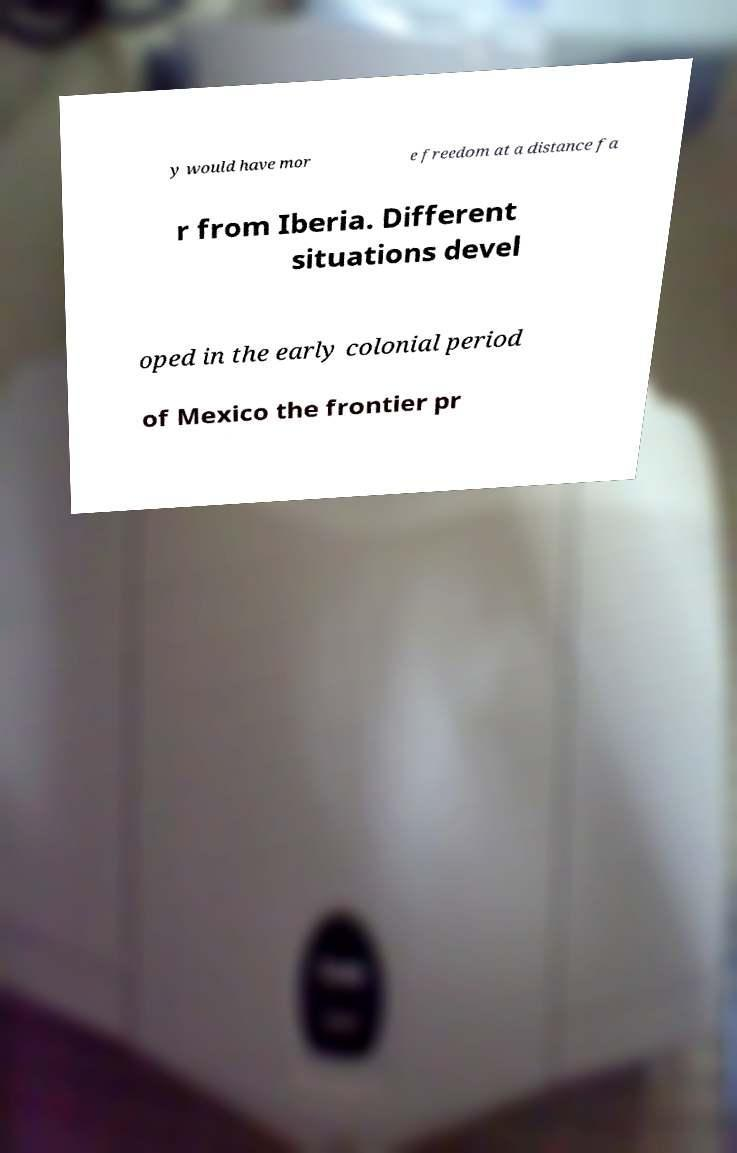Please identify and transcribe the text found in this image. y would have mor e freedom at a distance fa r from Iberia. Different situations devel oped in the early colonial period of Mexico the frontier pr 